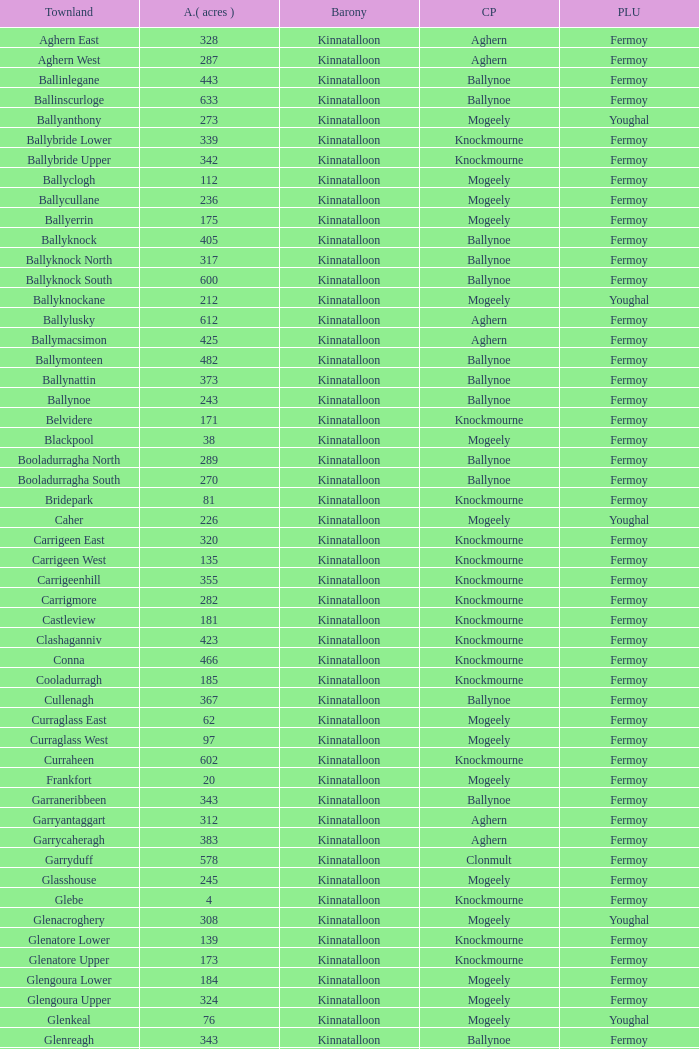Name  the townland for fermoy and ballynoe Ballinlegane, Ballinscurloge, Ballyknock, Ballyknock North, Ballyknock South, Ballymonteen, Ballynattin, Ballynoe, Booladurragha North, Booladurragha South, Cullenagh, Garraneribbeen, Glenreagh, Glentane, Killasseragh, Kilphillibeen, Knockakeo, Longueville North, Longueville South, Rathdrum, Shanaboola. 